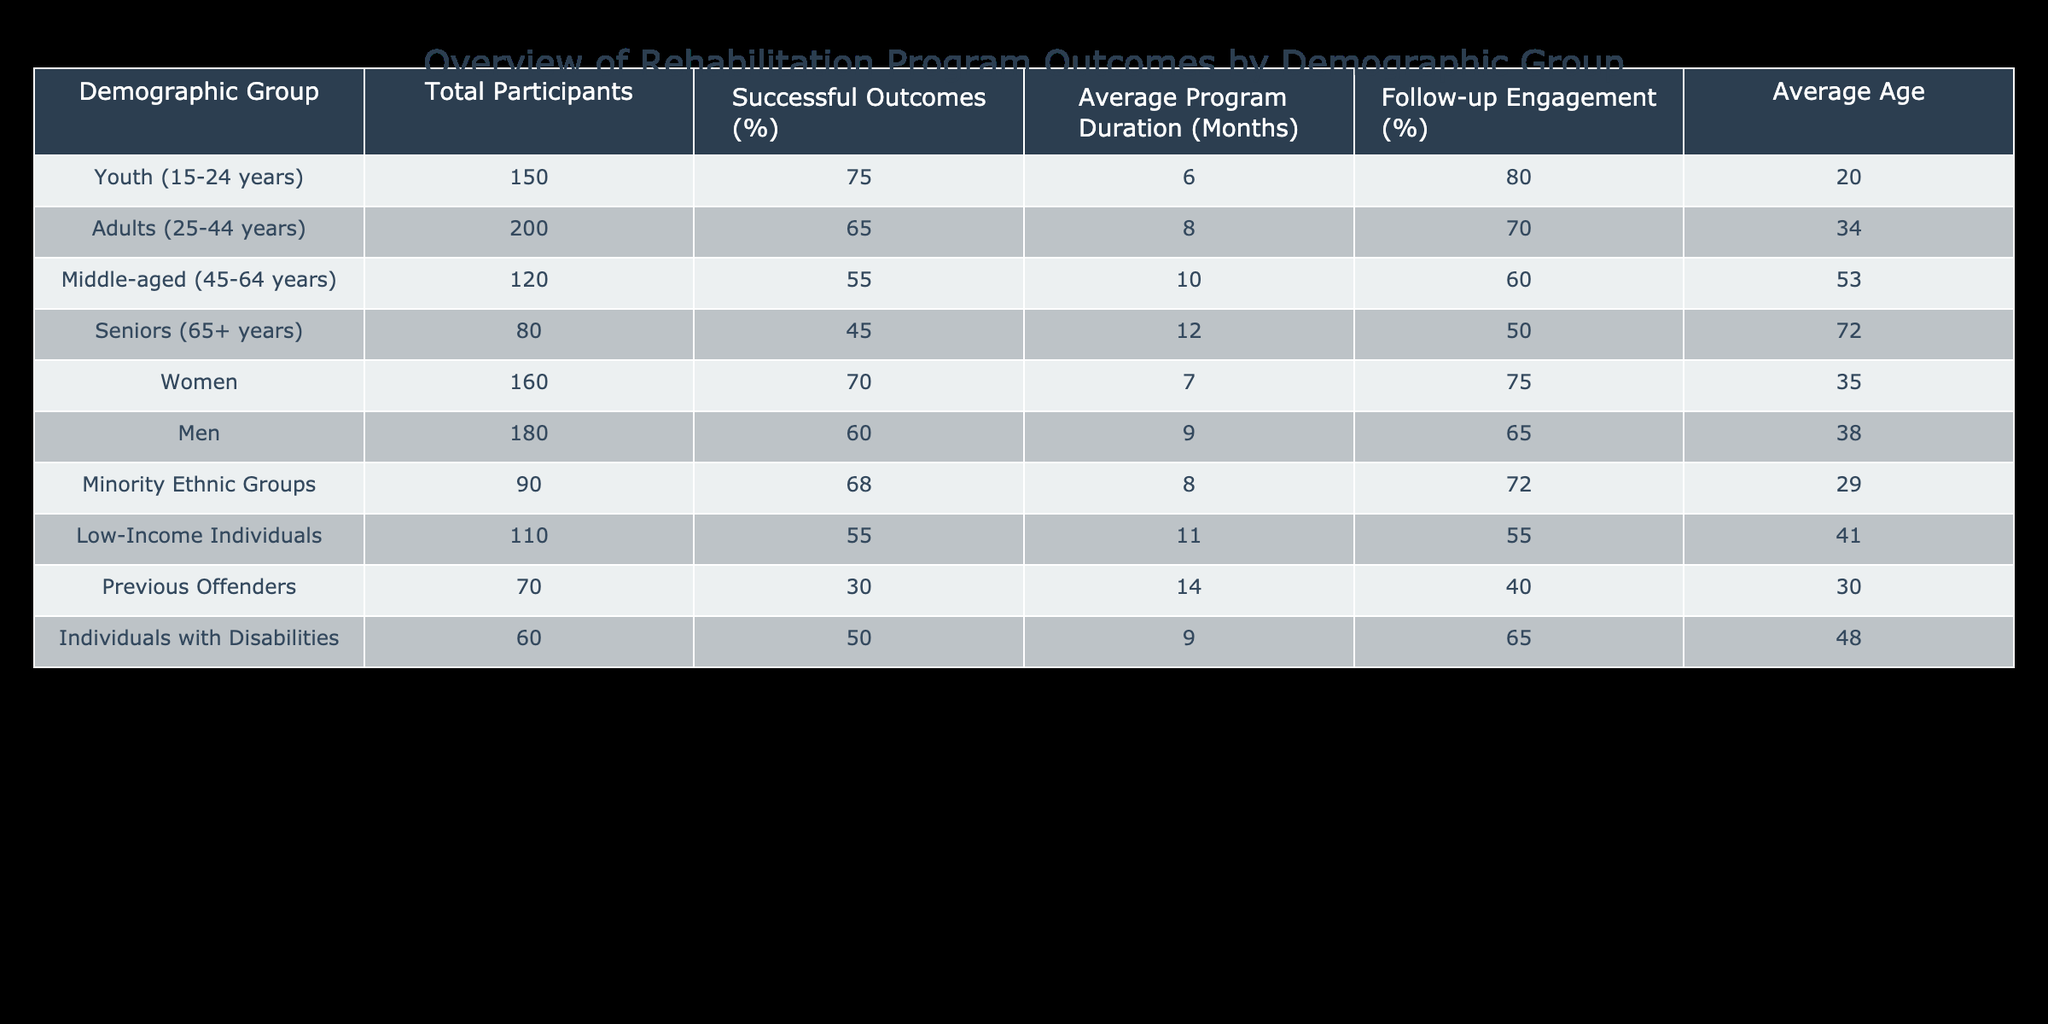What is the percentage of successful outcomes for the Youth demographic? From the table, the Youth demographic (15-24 years) has a successful outcomes percentage of 75%.
Answer: 75% Which demographic group has the lowest percentage of successful outcomes? By comparing the percentages of successful outcomes across all groups, the Seniors demographic (65+ years) has the lowest successful outcomes percentage at 45%.
Answer: Seniors (45%) What is the average program duration for Low-Income Individuals? According to the table, the Average Program Duration for Low-Income Individuals is 11 months.
Answer: 11 months What is the difference in average program duration between Middle-aged individuals and Youth? The Average Program Duration for Middle-aged individuals is 10 months and for Youth is 6 months. The difference is 10 - 6 = 4 months.
Answer: 4 months Is the follow-up engagement percentage for Women higher than that for Men? The follow-up engagement for Women is 75%, while for Men it is 65%. Since 75% is greater than 65%, the statement is true.
Answer: Yes What is the average age of Participants in Minority Ethnic Groups? The table shows that the average age for Minority Ethnic Groups is 29 years.
Answer: 29 Which demographic group has more successful outcomes, Adults or Individuals with Disabilities? The Adults demographic has a successful outcome percentage of 65%, while Individuals with Disabilities have 50%. Since 65% is greater than 50%, Adults have more successful outcomes.
Answer: Adults How many total participants are there in the Seniors demographic? The table indicates that there are 80 participants in the Seniors demographic (65+ years).
Answer: 80 What is the average successful outcome percentage across all groups? To find the average, we need to add all successful outcome percentages (75 + 65 + 55 + 45 + 70 + 60 + 68 + 55 + 30 + 50) = 675 and then divide by the number of groups (10), resulting in an average of 67.5%.
Answer: 67.5% 